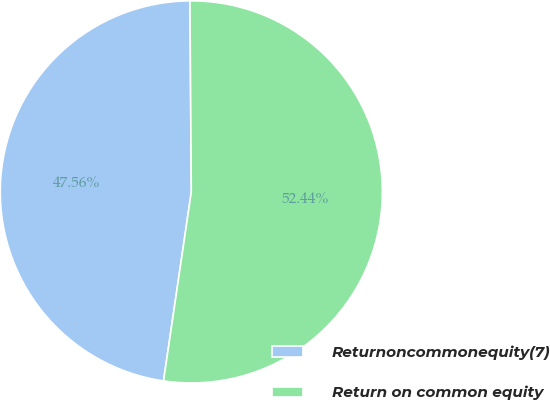Convert chart. <chart><loc_0><loc_0><loc_500><loc_500><pie_chart><fcel>Returnoncommonequity(7)<fcel>Return on common equity<nl><fcel>47.56%<fcel>52.44%<nl></chart> 